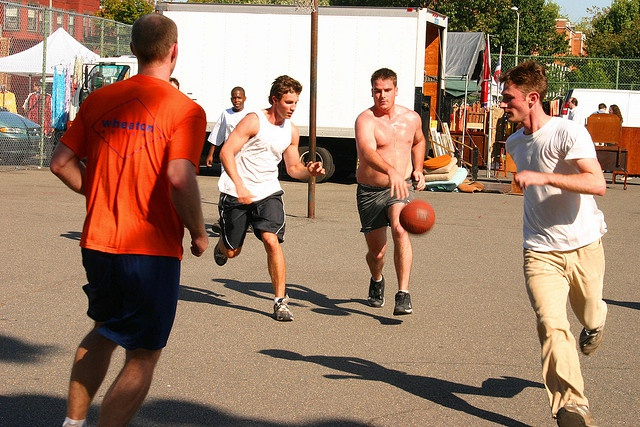Describe the objects in this image and their specific colors. I can see people in lightpink, black, maroon, and red tones, truck in lightpink, white, black, red, and tan tones, people in lightpink, ivory, tan, and gray tones, people in lightpink, white, black, tan, and salmon tones, and people in lightpink, maroon, tan, and black tones in this image. 